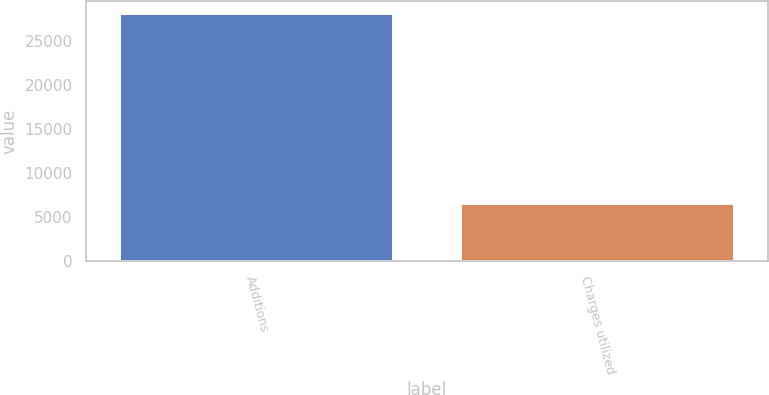<chart> <loc_0><loc_0><loc_500><loc_500><bar_chart><fcel>Additions<fcel>Charges utilized<nl><fcel>28097<fcel>6486<nl></chart> 